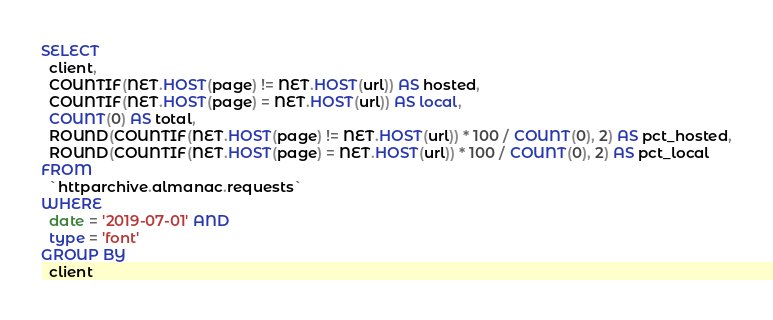<code> <loc_0><loc_0><loc_500><loc_500><_SQL_>SELECT
  client,
  COUNTIF(NET.HOST(page) != NET.HOST(url)) AS hosted,
  COUNTIF(NET.HOST(page) = NET.HOST(url)) AS local,
  COUNT(0) AS total,
  ROUND(COUNTIF(NET.HOST(page) != NET.HOST(url)) * 100 / COUNT(0), 2) AS pct_hosted,
  ROUND(COUNTIF(NET.HOST(page) = NET.HOST(url)) * 100 / COUNT(0), 2) AS pct_local
FROM
  `httparchive.almanac.requests`
WHERE
  date = '2019-07-01' AND
  type = 'font'
GROUP BY
  client
</code> 